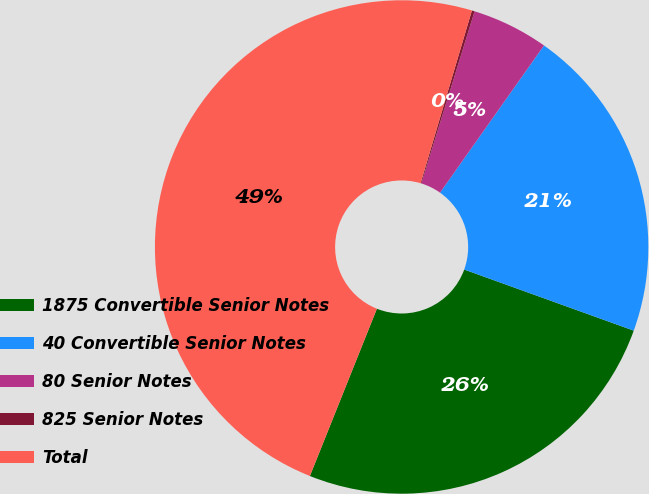Convert chart to OTSL. <chart><loc_0><loc_0><loc_500><loc_500><pie_chart><fcel>1875 Convertible Senior Notes<fcel>40 Convertible Senior Notes<fcel>80 Senior Notes<fcel>825 Senior Notes<fcel>Total<nl><fcel>25.56%<fcel>20.72%<fcel>5.01%<fcel>0.18%<fcel>48.54%<nl></chart> 